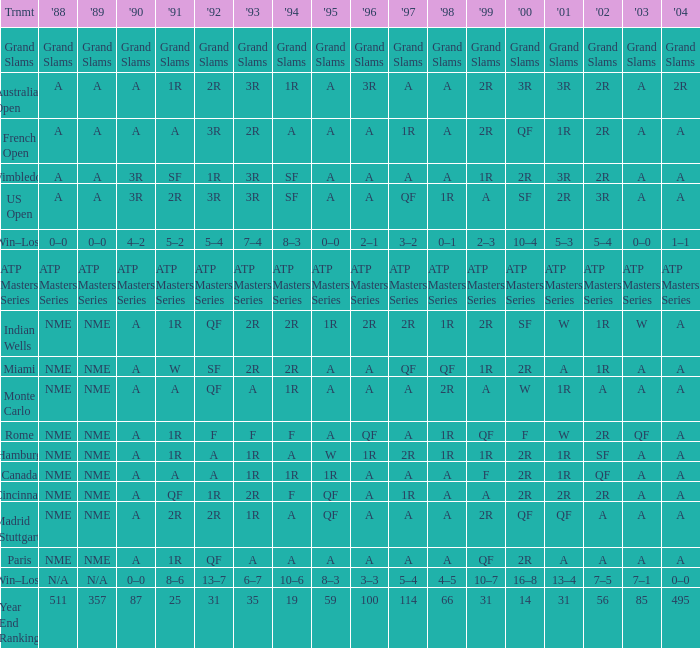What shows for 1992 when 2001 is 1r, 1994 is 1r, and the 2002 is qf? A. 